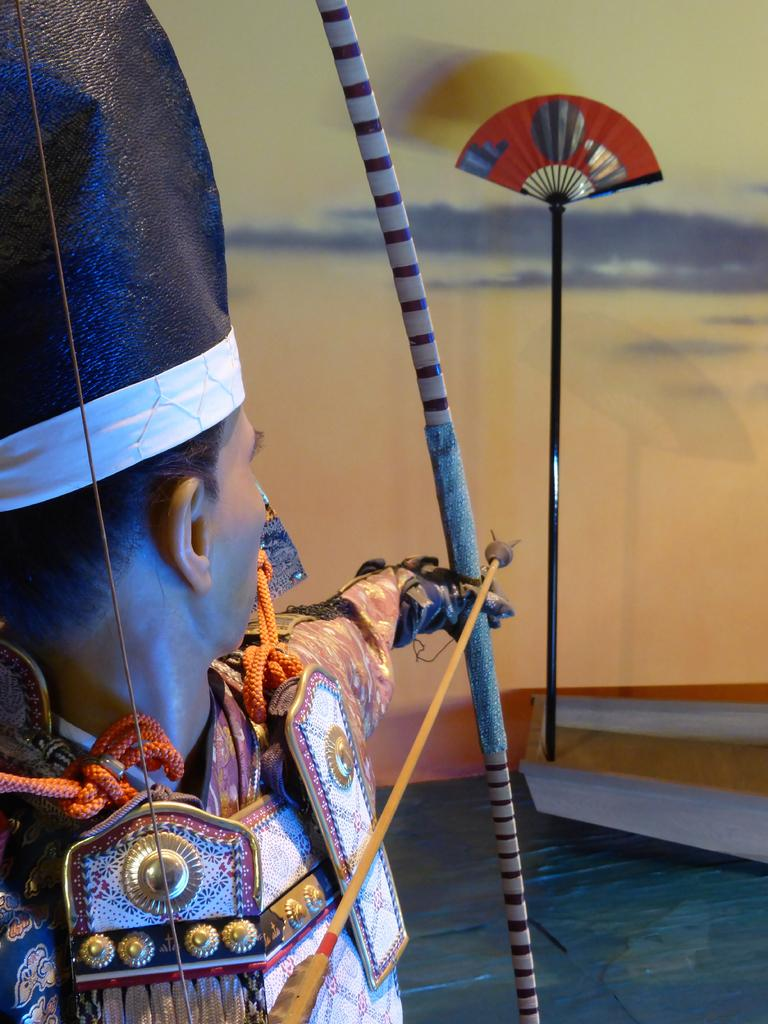What is the person in the image holding? The person is holding a bow and an arrow in the image. What object with a stand can be seen in the image? There is a paper fan with a stand in the image. What is visible in the background of the image? There is a wall in the background of the image. How many chairs are present in the image? There are no chairs visible in the image. 